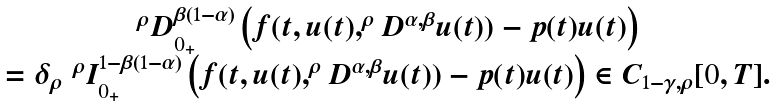<formula> <loc_0><loc_0><loc_500><loc_500>\begin{array} { c c } ^ { \rho } D ^ { \beta ( 1 - \alpha ) } _ { 0 _ { + } } \left ( f ( t , u ( t ) , ^ { \rho } D ^ { \alpha , \beta } u ( t ) ) - p ( t ) u ( t ) \right ) \\ = \delta _ { \rho } \ ^ { \rho } I ^ { 1 - \beta ( 1 - \alpha ) } _ { 0 _ { + } } \left ( f ( t , u ( t ) , ^ { \rho } D ^ { \alpha , \beta } u ( t ) ) - p ( t ) u ( t ) \right ) \in C _ { 1 - \gamma , \rho } [ 0 , T ] . \end{array}</formula> 